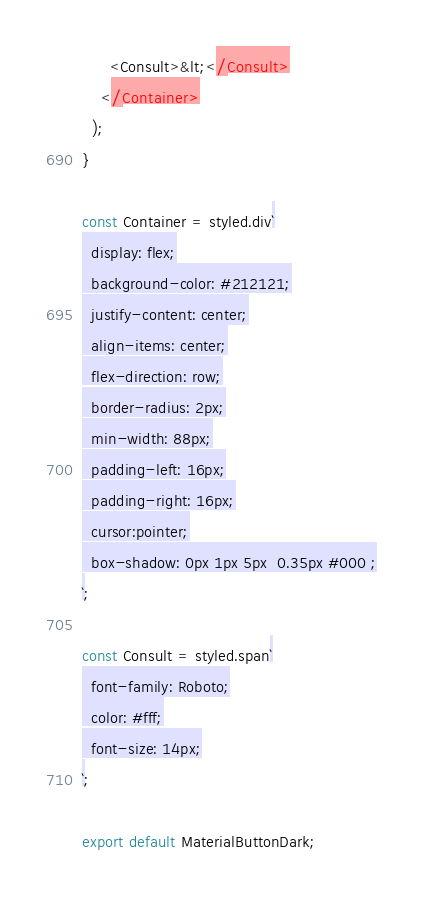<code> <loc_0><loc_0><loc_500><loc_500><_JavaScript_>      <Consult>&lt;</Consult>
    </Container>
  );
}

const Container = styled.div`
  display: flex;
  background-color: #212121;
  justify-content: center;
  align-items: center;
  flex-direction: row;
  border-radius: 2px;
  min-width: 88px;
  padding-left: 16px;
  padding-right: 16px;
  cursor:pointer;
  box-shadow: 0px 1px 5px  0.35px #000 ;
`;

const Consult = styled.span`
  font-family: Roboto;
  color: #fff;
  font-size: 14px;
`;

export default MaterialButtonDark;
</code> 